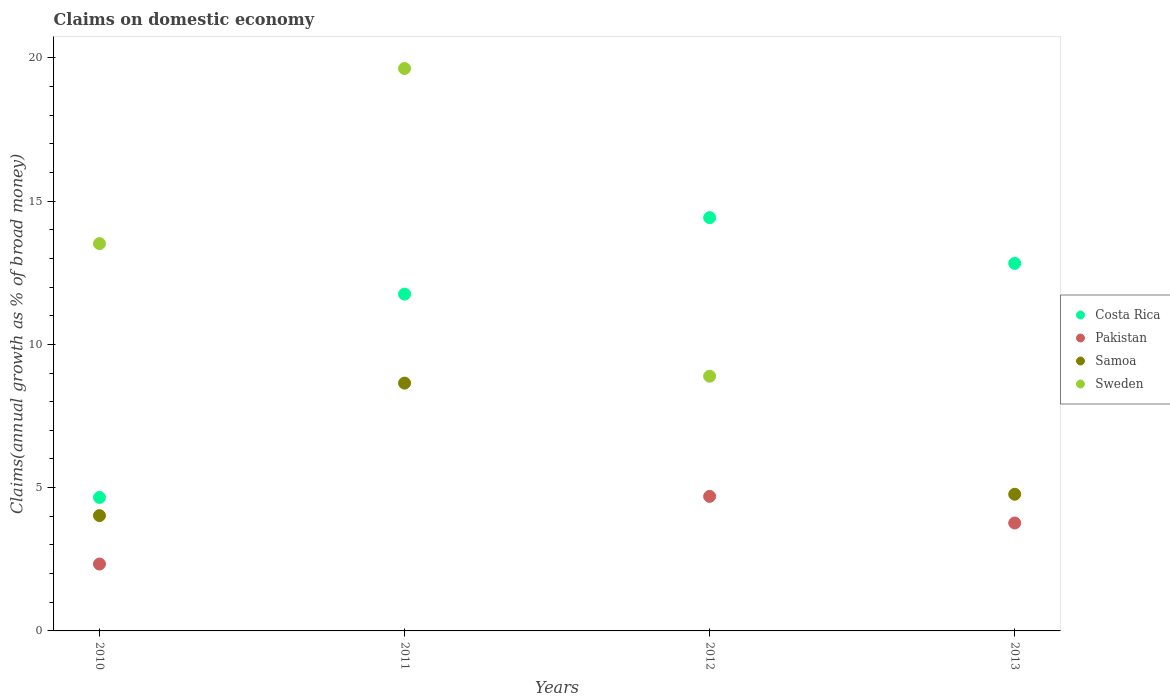What is the percentage of broad money claimed on domestic economy in Sweden in 2012?
Offer a terse response. 8.89. Across all years, what is the maximum percentage of broad money claimed on domestic economy in Samoa?
Offer a very short reply. 8.65. What is the total percentage of broad money claimed on domestic economy in Samoa in the graph?
Provide a short and direct response. 17.44. What is the difference between the percentage of broad money claimed on domestic economy in Samoa in 2010 and that in 2011?
Offer a very short reply. -4.62. What is the difference between the percentage of broad money claimed on domestic economy in Pakistan in 2010 and the percentage of broad money claimed on domestic economy in Samoa in 2012?
Your response must be concise. 2.33. What is the average percentage of broad money claimed on domestic economy in Pakistan per year?
Give a very brief answer. 2.7. In the year 2012, what is the difference between the percentage of broad money claimed on domestic economy in Sweden and percentage of broad money claimed on domestic economy in Costa Rica?
Ensure brevity in your answer.  -5.53. What is the ratio of the percentage of broad money claimed on domestic economy in Samoa in 2010 to that in 2011?
Keep it short and to the point. 0.47. Is the difference between the percentage of broad money claimed on domestic economy in Sweden in 2011 and 2012 greater than the difference between the percentage of broad money claimed on domestic economy in Costa Rica in 2011 and 2012?
Provide a short and direct response. Yes. What is the difference between the highest and the second highest percentage of broad money claimed on domestic economy in Samoa?
Your answer should be compact. 3.88. What is the difference between the highest and the lowest percentage of broad money claimed on domestic economy in Pakistan?
Provide a succinct answer. 4.7. Is the sum of the percentage of broad money claimed on domestic economy in Costa Rica in 2010 and 2011 greater than the maximum percentage of broad money claimed on domestic economy in Sweden across all years?
Keep it short and to the point. No. How many dotlines are there?
Keep it short and to the point. 4. How many years are there in the graph?
Your answer should be very brief. 4. What is the difference between two consecutive major ticks on the Y-axis?
Provide a succinct answer. 5. Are the values on the major ticks of Y-axis written in scientific E-notation?
Offer a terse response. No. Does the graph contain any zero values?
Make the answer very short. Yes. How many legend labels are there?
Provide a short and direct response. 4. How are the legend labels stacked?
Provide a succinct answer. Vertical. What is the title of the graph?
Give a very brief answer. Claims on domestic economy. What is the label or title of the X-axis?
Provide a succinct answer. Years. What is the label or title of the Y-axis?
Your response must be concise. Claims(annual growth as % of broad money). What is the Claims(annual growth as % of broad money) in Costa Rica in 2010?
Ensure brevity in your answer.  4.66. What is the Claims(annual growth as % of broad money) of Pakistan in 2010?
Provide a short and direct response. 2.33. What is the Claims(annual growth as % of broad money) in Samoa in 2010?
Give a very brief answer. 4.02. What is the Claims(annual growth as % of broad money) in Sweden in 2010?
Your response must be concise. 13.52. What is the Claims(annual growth as % of broad money) in Costa Rica in 2011?
Keep it short and to the point. 11.75. What is the Claims(annual growth as % of broad money) of Samoa in 2011?
Offer a terse response. 8.65. What is the Claims(annual growth as % of broad money) in Sweden in 2011?
Offer a very short reply. 19.63. What is the Claims(annual growth as % of broad money) in Costa Rica in 2012?
Offer a very short reply. 14.42. What is the Claims(annual growth as % of broad money) in Pakistan in 2012?
Provide a short and direct response. 4.7. What is the Claims(annual growth as % of broad money) in Sweden in 2012?
Offer a very short reply. 8.89. What is the Claims(annual growth as % of broad money) of Costa Rica in 2013?
Provide a short and direct response. 12.83. What is the Claims(annual growth as % of broad money) of Pakistan in 2013?
Make the answer very short. 3.77. What is the Claims(annual growth as % of broad money) of Samoa in 2013?
Make the answer very short. 4.77. What is the Claims(annual growth as % of broad money) in Sweden in 2013?
Give a very brief answer. 0. Across all years, what is the maximum Claims(annual growth as % of broad money) in Costa Rica?
Keep it short and to the point. 14.42. Across all years, what is the maximum Claims(annual growth as % of broad money) in Pakistan?
Your response must be concise. 4.7. Across all years, what is the maximum Claims(annual growth as % of broad money) of Samoa?
Your answer should be compact. 8.65. Across all years, what is the maximum Claims(annual growth as % of broad money) of Sweden?
Your answer should be compact. 19.63. Across all years, what is the minimum Claims(annual growth as % of broad money) in Costa Rica?
Give a very brief answer. 4.66. Across all years, what is the minimum Claims(annual growth as % of broad money) of Pakistan?
Provide a short and direct response. 0. Across all years, what is the minimum Claims(annual growth as % of broad money) in Sweden?
Offer a terse response. 0. What is the total Claims(annual growth as % of broad money) of Costa Rica in the graph?
Your response must be concise. 43.66. What is the total Claims(annual growth as % of broad money) of Pakistan in the graph?
Keep it short and to the point. 10.8. What is the total Claims(annual growth as % of broad money) in Samoa in the graph?
Your answer should be compact. 17.44. What is the total Claims(annual growth as % of broad money) in Sweden in the graph?
Ensure brevity in your answer.  42.03. What is the difference between the Claims(annual growth as % of broad money) of Costa Rica in 2010 and that in 2011?
Keep it short and to the point. -7.1. What is the difference between the Claims(annual growth as % of broad money) in Samoa in 2010 and that in 2011?
Your answer should be compact. -4.62. What is the difference between the Claims(annual growth as % of broad money) of Sweden in 2010 and that in 2011?
Your answer should be compact. -6.11. What is the difference between the Claims(annual growth as % of broad money) of Costa Rica in 2010 and that in 2012?
Keep it short and to the point. -9.77. What is the difference between the Claims(annual growth as % of broad money) in Pakistan in 2010 and that in 2012?
Provide a short and direct response. -2.36. What is the difference between the Claims(annual growth as % of broad money) in Sweden in 2010 and that in 2012?
Provide a short and direct response. 4.63. What is the difference between the Claims(annual growth as % of broad money) in Costa Rica in 2010 and that in 2013?
Provide a succinct answer. -8.17. What is the difference between the Claims(annual growth as % of broad money) of Pakistan in 2010 and that in 2013?
Your answer should be compact. -1.43. What is the difference between the Claims(annual growth as % of broad money) of Samoa in 2010 and that in 2013?
Your response must be concise. -0.75. What is the difference between the Claims(annual growth as % of broad money) of Costa Rica in 2011 and that in 2012?
Your answer should be compact. -2.67. What is the difference between the Claims(annual growth as % of broad money) of Sweden in 2011 and that in 2012?
Provide a short and direct response. 10.74. What is the difference between the Claims(annual growth as % of broad money) of Costa Rica in 2011 and that in 2013?
Give a very brief answer. -1.07. What is the difference between the Claims(annual growth as % of broad money) in Samoa in 2011 and that in 2013?
Provide a succinct answer. 3.88. What is the difference between the Claims(annual growth as % of broad money) in Costa Rica in 2012 and that in 2013?
Your answer should be compact. 1.6. What is the difference between the Claims(annual growth as % of broad money) in Pakistan in 2012 and that in 2013?
Give a very brief answer. 0.93. What is the difference between the Claims(annual growth as % of broad money) in Costa Rica in 2010 and the Claims(annual growth as % of broad money) in Samoa in 2011?
Offer a terse response. -3.99. What is the difference between the Claims(annual growth as % of broad money) in Costa Rica in 2010 and the Claims(annual growth as % of broad money) in Sweden in 2011?
Give a very brief answer. -14.97. What is the difference between the Claims(annual growth as % of broad money) in Pakistan in 2010 and the Claims(annual growth as % of broad money) in Samoa in 2011?
Your response must be concise. -6.31. What is the difference between the Claims(annual growth as % of broad money) in Pakistan in 2010 and the Claims(annual growth as % of broad money) in Sweden in 2011?
Give a very brief answer. -17.29. What is the difference between the Claims(annual growth as % of broad money) in Samoa in 2010 and the Claims(annual growth as % of broad money) in Sweden in 2011?
Provide a succinct answer. -15.6. What is the difference between the Claims(annual growth as % of broad money) in Costa Rica in 2010 and the Claims(annual growth as % of broad money) in Pakistan in 2012?
Your answer should be very brief. -0.04. What is the difference between the Claims(annual growth as % of broad money) of Costa Rica in 2010 and the Claims(annual growth as % of broad money) of Sweden in 2012?
Offer a terse response. -4.23. What is the difference between the Claims(annual growth as % of broad money) of Pakistan in 2010 and the Claims(annual growth as % of broad money) of Sweden in 2012?
Give a very brief answer. -6.55. What is the difference between the Claims(annual growth as % of broad money) of Samoa in 2010 and the Claims(annual growth as % of broad money) of Sweden in 2012?
Your response must be concise. -4.86. What is the difference between the Claims(annual growth as % of broad money) of Costa Rica in 2010 and the Claims(annual growth as % of broad money) of Pakistan in 2013?
Your answer should be compact. 0.89. What is the difference between the Claims(annual growth as % of broad money) of Costa Rica in 2010 and the Claims(annual growth as % of broad money) of Samoa in 2013?
Offer a very short reply. -0.11. What is the difference between the Claims(annual growth as % of broad money) of Pakistan in 2010 and the Claims(annual growth as % of broad money) of Samoa in 2013?
Offer a terse response. -2.43. What is the difference between the Claims(annual growth as % of broad money) of Costa Rica in 2011 and the Claims(annual growth as % of broad money) of Pakistan in 2012?
Give a very brief answer. 7.06. What is the difference between the Claims(annual growth as % of broad money) of Costa Rica in 2011 and the Claims(annual growth as % of broad money) of Sweden in 2012?
Offer a very short reply. 2.87. What is the difference between the Claims(annual growth as % of broad money) of Samoa in 2011 and the Claims(annual growth as % of broad money) of Sweden in 2012?
Provide a succinct answer. -0.24. What is the difference between the Claims(annual growth as % of broad money) of Costa Rica in 2011 and the Claims(annual growth as % of broad money) of Pakistan in 2013?
Make the answer very short. 7.99. What is the difference between the Claims(annual growth as % of broad money) of Costa Rica in 2011 and the Claims(annual growth as % of broad money) of Samoa in 2013?
Offer a very short reply. 6.98. What is the difference between the Claims(annual growth as % of broad money) of Costa Rica in 2012 and the Claims(annual growth as % of broad money) of Pakistan in 2013?
Your response must be concise. 10.66. What is the difference between the Claims(annual growth as % of broad money) of Costa Rica in 2012 and the Claims(annual growth as % of broad money) of Samoa in 2013?
Give a very brief answer. 9.65. What is the difference between the Claims(annual growth as % of broad money) of Pakistan in 2012 and the Claims(annual growth as % of broad money) of Samoa in 2013?
Keep it short and to the point. -0.07. What is the average Claims(annual growth as % of broad money) of Costa Rica per year?
Offer a very short reply. 10.92. What is the average Claims(annual growth as % of broad money) in Pakistan per year?
Offer a terse response. 2.7. What is the average Claims(annual growth as % of broad money) of Samoa per year?
Offer a very short reply. 4.36. What is the average Claims(annual growth as % of broad money) of Sweden per year?
Offer a terse response. 10.51. In the year 2010, what is the difference between the Claims(annual growth as % of broad money) of Costa Rica and Claims(annual growth as % of broad money) of Pakistan?
Provide a succinct answer. 2.32. In the year 2010, what is the difference between the Claims(annual growth as % of broad money) in Costa Rica and Claims(annual growth as % of broad money) in Samoa?
Offer a terse response. 0.63. In the year 2010, what is the difference between the Claims(annual growth as % of broad money) in Costa Rica and Claims(annual growth as % of broad money) in Sweden?
Keep it short and to the point. -8.86. In the year 2010, what is the difference between the Claims(annual growth as % of broad money) of Pakistan and Claims(annual growth as % of broad money) of Samoa?
Make the answer very short. -1.69. In the year 2010, what is the difference between the Claims(annual growth as % of broad money) of Pakistan and Claims(annual growth as % of broad money) of Sweden?
Your answer should be compact. -11.18. In the year 2010, what is the difference between the Claims(annual growth as % of broad money) in Samoa and Claims(annual growth as % of broad money) in Sweden?
Your answer should be compact. -9.49. In the year 2011, what is the difference between the Claims(annual growth as % of broad money) in Costa Rica and Claims(annual growth as % of broad money) in Samoa?
Your answer should be very brief. 3.11. In the year 2011, what is the difference between the Claims(annual growth as % of broad money) in Costa Rica and Claims(annual growth as % of broad money) in Sweden?
Your response must be concise. -7.87. In the year 2011, what is the difference between the Claims(annual growth as % of broad money) in Samoa and Claims(annual growth as % of broad money) in Sweden?
Give a very brief answer. -10.98. In the year 2012, what is the difference between the Claims(annual growth as % of broad money) in Costa Rica and Claims(annual growth as % of broad money) in Pakistan?
Give a very brief answer. 9.73. In the year 2012, what is the difference between the Claims(annual growth as % of broad money) of Costa Rica and Claims(annual growth as % of broad money) of Sweden?
Keep it short and to the point. 5.53. In the year 2012, what is the difference between the Claims(annual growth as % of broad money) in Pakistan and Claims(annual growth as % of broad money) in Sweden?
Provide a succinct answer. -4.19. In the year 2013, what is the difference between the Claims(annual growth as % of broad money) in Costa Rica and Claims(annual growth as % of broad money) in Pakistan?
Provide a succinct answer. 9.06. In the year 2013, what is the difference between the Claims(annual growth as % of broad money) in Costa Rica and Claims(annual growth as % of broad money) in Samoa?
Your response must be concise. 8.06. In the year 2013, what is the difference between the Claims(annual growth as % of broad money) in Pakistan and Claims(annual growth as % of broad money) in Samoa?
Your answer should be compact. -1. What is the ratio of the Claims(annual growth as % of broad money) of Costa Rica in 2010 to that in 2011?
Provide a succinct answer. 0.4. What is the ratio of the Claims(annual growth as % of broad money) in Samoa in 2010 to that in 2011?
Your answer should be very brief. 0.47. What is the ratio of the Claims(annual growth as % of broad money) in Sweden in 2010 to that in 2011?
Provide a succinct answer. 0.69. What is the ratio of the Claims(annual growth as % of broad money) of Costa Rica in 2010 to that in 2012?
Provide a short and direct response. 0.32. What is the ratio of the Claims(annual growth as % of broad money) in Pakistan in 2010 to that in 2012?
Your answer should be very brief. 0.5. What is the ratio of the Claims(annual growth as % of broad money) in Sweden in 2010 to that in 2012?
Make the answer very short. 1.52. What is the ratio of the Claims(annual growth as % of broad money) in Costa Rica in 2010 to that in 2013?
Your answer should be compact. 0.36. What is the ratio of the Claims(annual growth as % of broad money) of Pakistan in 2010 to that in 2013?
Offer a terse response. 0.62. What is the ratio of the Claims(annual growth as % of broad money) of Samoa in 2010 to that in 2013?
Provide a short and direct response. 0.84. What is the ratio of the Claims(annual growth as % of broad money) of Costa Rica in 2011 to that in 2012?
Ensure brevity in your answer.  0.81. What is the ratio of the Claims(annual growth as % of broad money) of Sweden in 2011 to that in 2012?
Make the answer very short. 2.21. What is the ratio of the Claims(annual growth as % of broad money) of Costa Rica in 2011 to that in 2013?
Keep it short and to the point. 0.92. What is the ratio of the Claims(annual growth as % of broad money) of Samoa in 2011 to that in 2013?
Keep it short and to the point. 1.81. What is the ratio of the Claims(annual growth as % of broad money) of Costa Rica in 2012 to that in 2013?
Keep it short and to the point. 1.12. What is the ratio of the Claims(annual growth as % of broad money) in Pakistan in 2012 to that in 2013?
Your response must be concise. 1.25. What is the difference between the highest and the second highest Claims(annual growth as % of broad money) of Costa Rica?
Your response must be concise. 1.6. What is the difference between the highest and the second highest Claims(annual growth as % of broad money) of Pakistan?
Your response must be concise. 0.93. What is the difference between the highest and the second highest Claims(annual growth as % of broad money) in Samoa?
Your answer should be very brief. 3.88. What is the difference between the highest and the second highest Claims(annual growth as % of broad money) in Sweden?
Make the answer very short. 6.11. What is the difference between the highest and the lowest Claims(annual growth as % of broad money) in Costa Rica?
Offer a very short reply. 9.77. What is the difference between the highest and the lowest Claims(annual growth as % of broad money) in Pakistan?
Provide a short and direct response. 4.7. What is the difference between the highest and the lowest Claims(annual growth as % of broad money) of Samoa?
Offer a terse response. 8.65. What is the difference between the highest and the lowest Claims(annual growth as % of broad money) in Sweden?
Offer a very short reply. 19.63. 